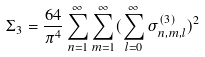Convert formula to latex. <formula><loc_0><loc_0><loc_500><loc_500>\Sigma _ { 3 } = \frac { 6 4 } { \pi ^ { 4 } } \sum _ { n = 1 } ^ { \infty } \sum _ { m = 1 } ^ { \infty } ( \sum _ { l = 0 } ^ { \infty } \sigma _ { n , m , l } ^ { ( 3 ) } ) ^ { 2 }</formula> 